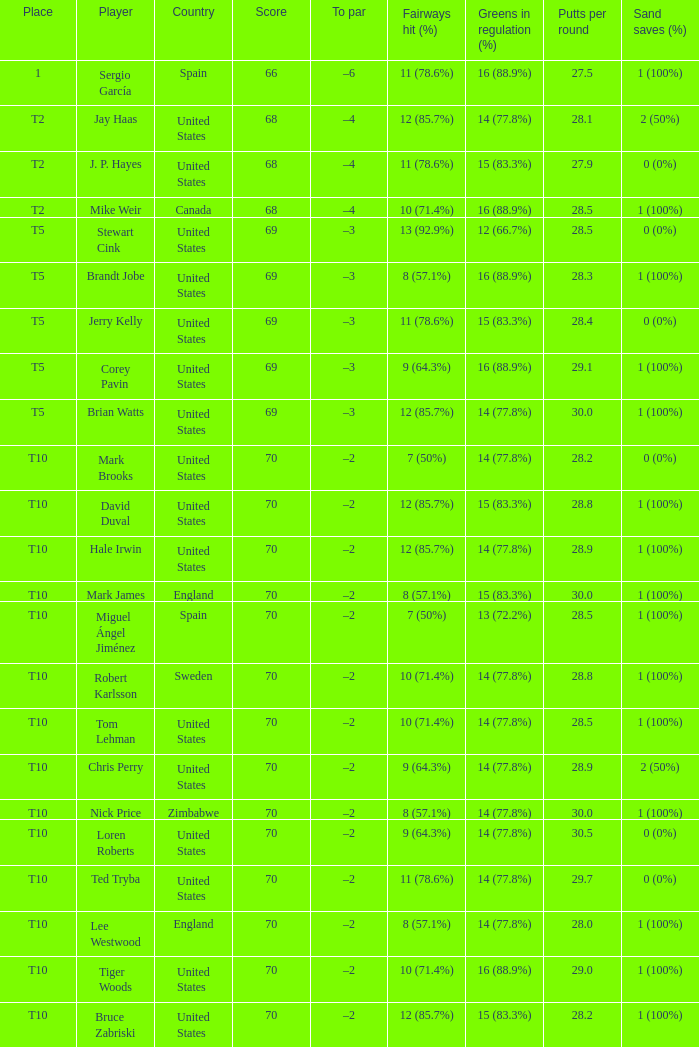Which player had a score of 70? Mark Brooks, David Duval, Hale Irwin, Mark James, Miguel Ángel Jiménez, Robert Karlsson, Tom Lehman, Chris Perry, Nick Price, Loren Roberts, Ted Tryba, Lee Westwood, Tiger Woods, Bruce Zabriski. 